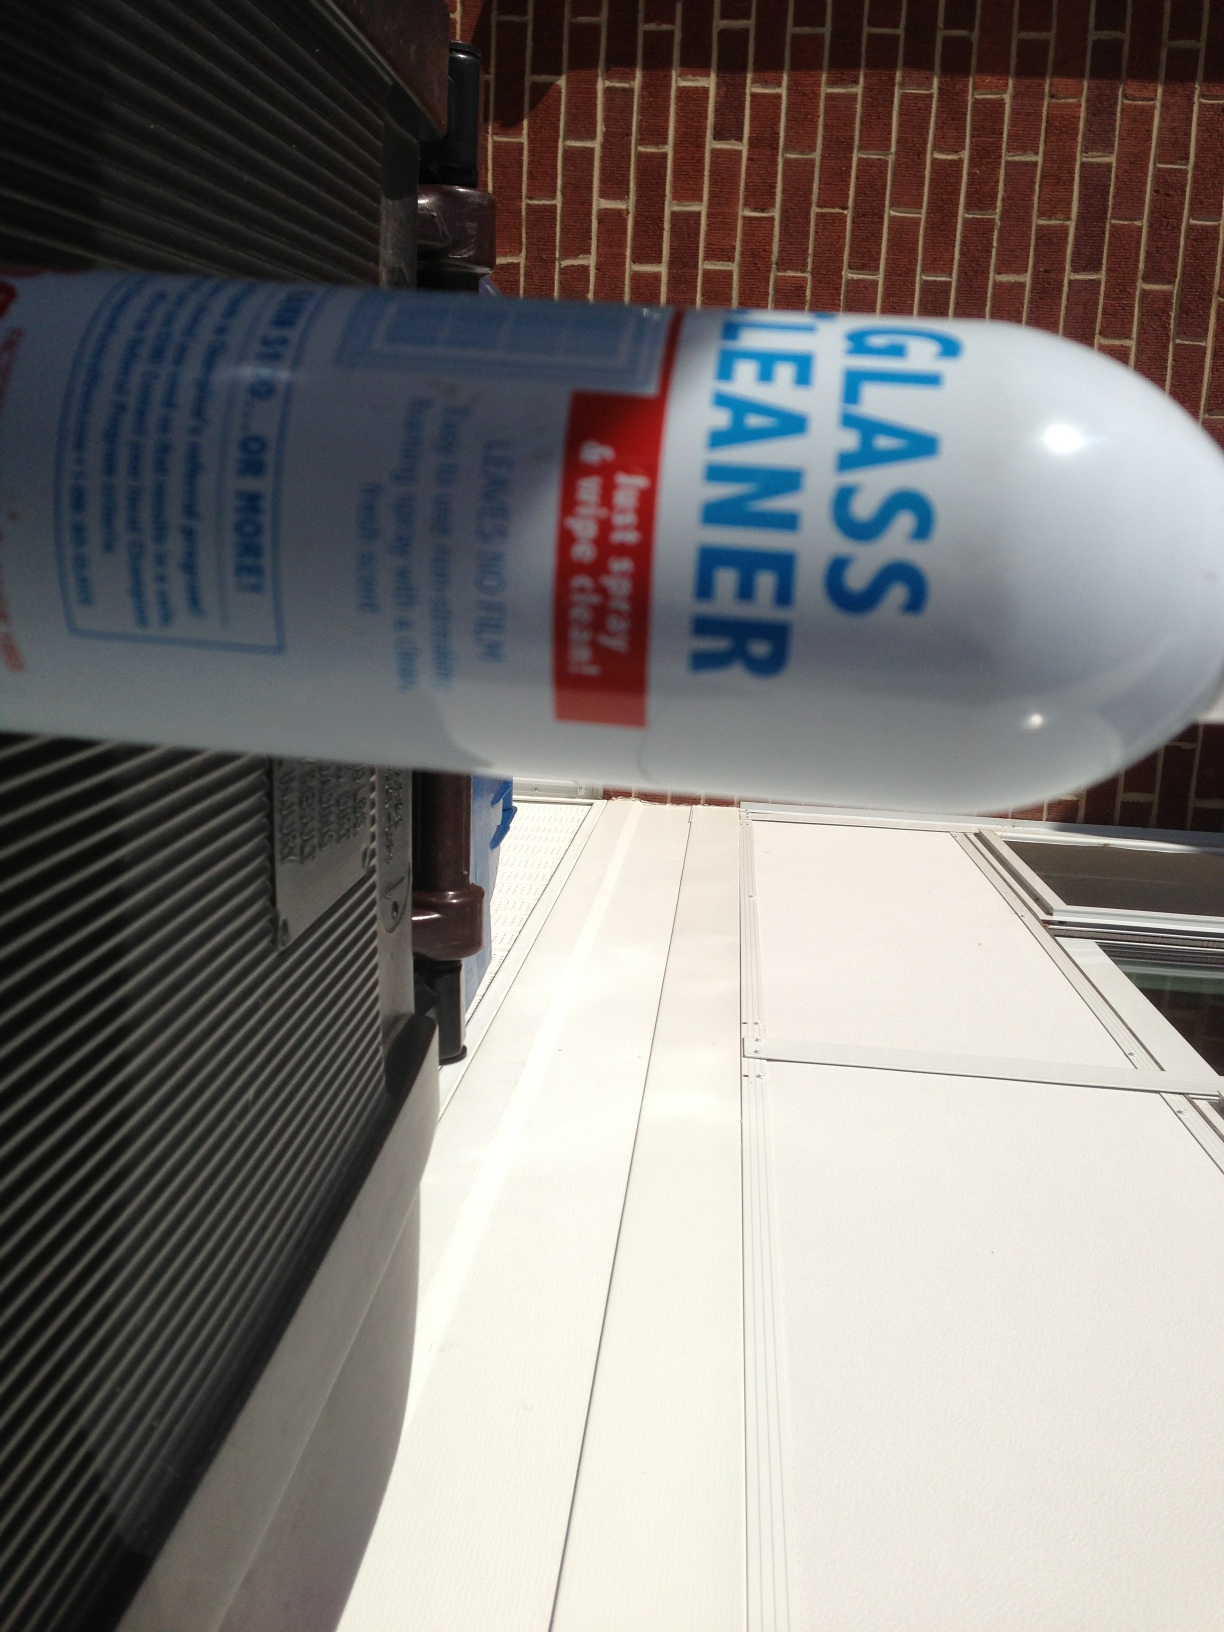What is in this can? The can in the image is labeled as 'glass cleaner', indicating that it contains a liquid solution designed for cleaning glass surfaces such as windows and mirrors to a streak-free shine. 